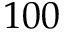Convert formula to latex. <formula><loc_0><loc_0><loc_500><loc_500>1 0 0</formula> 